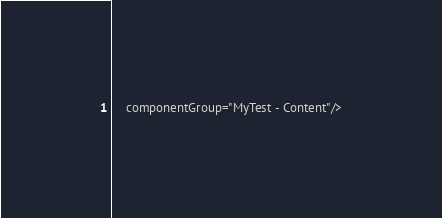Convert code to text. <code><loc_0><loc_0><loc_500><loc_500><_XML_>    componentGroup="MyTest - Content"/>
</code> 